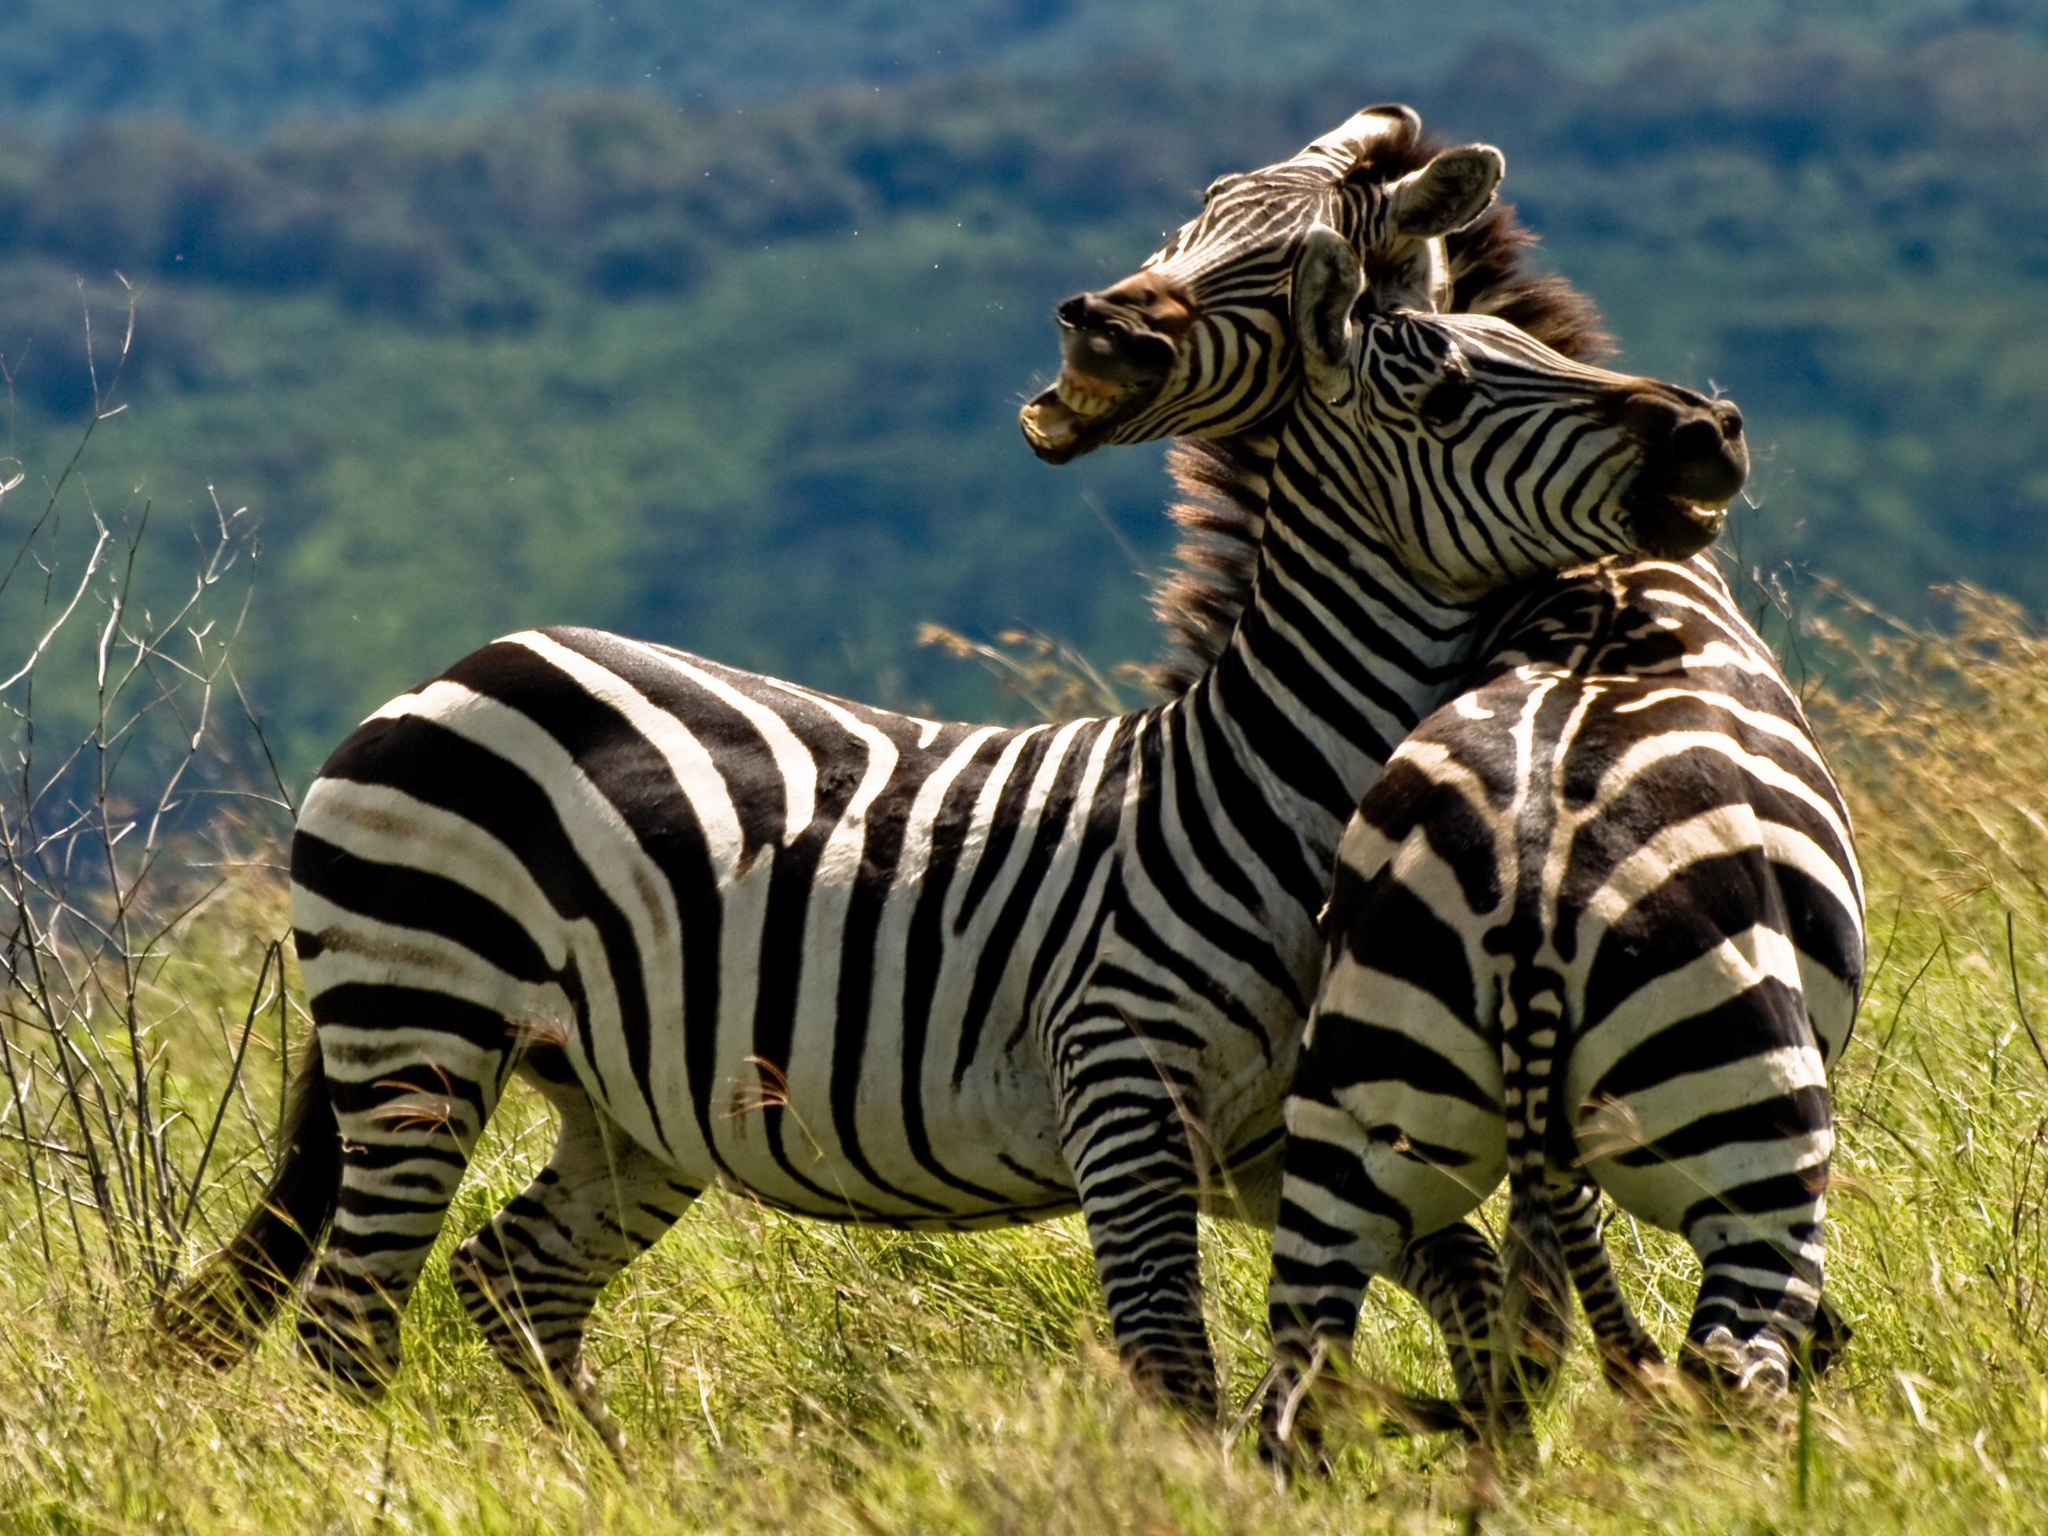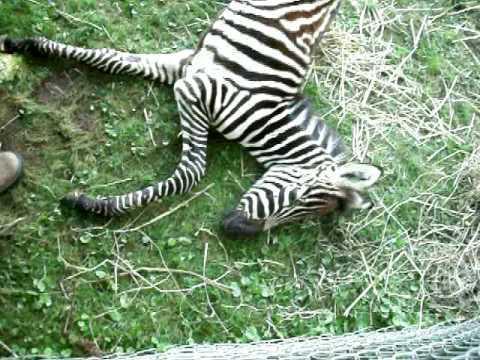The first image is the image on the left, the second image is the image on the right. Considering the images on both sides, is "One of the images features a single zebra laying completely sideways on the ground." valid? Answer yes or no. Yes. The first image is the image on the left, the second image is the image on the right. Assess this claim about the two images: "One image includes a zebra lying completely flat on the ground, and the othe image includes a zebra with its head lifted, mouth open and teeth showing in a braying pose.". Correct or not? Answer yes or no. Yes. 